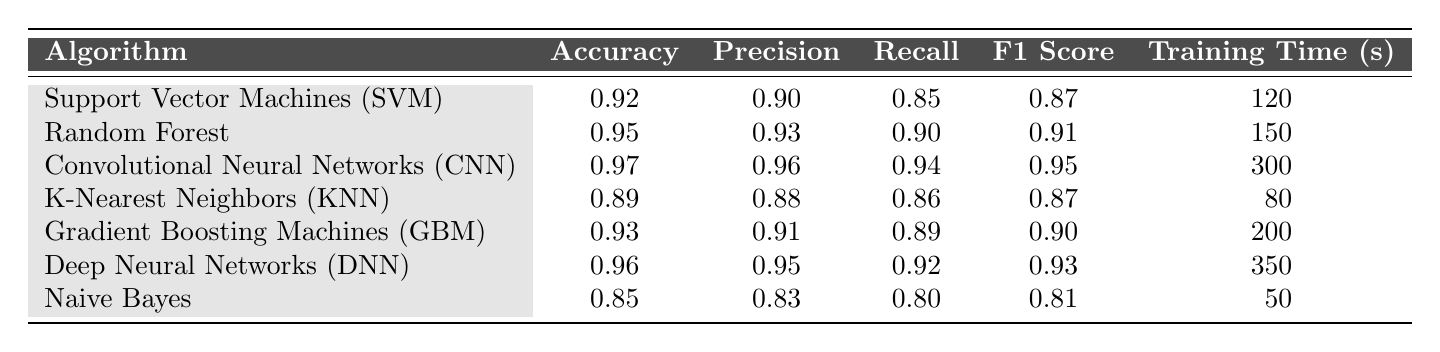What is the accuracy of the Convolutional Neural Networks (CNN)? The accuracy is listed directly under the respective row for CNN in the table, which shows 0.97.
Answer: 0.97 Which algorithm has the lowest precision? By examining the precision values given for each algorithm, Naive Bayes has the lowest precision at 0.83.
Answer: Naive Bayes What is the training time of the Random Forest algorithm? The training time for the Random Forest algorithm is explicitly stated in the table as 150 seconds.
Answer: 150 seconds True or False: The Deep Neural Networks (DNN) algorithm has a higher recall than the Gradient Boosting Machines (GBM). Comparing the recall values of DNN (0.92) and GBM (0.89) shows that DNN has a higher recall, making the statement true.
Answer: True What is the average accuracy of all the algorithms listed? The accuracies are 0.92, 0.95, 0.97, 0.89, 0.93, 0.96, and 0.85. Their sum is 0.92 + 0.95 + 0.97 + 0.89 + 0.93 + 0.96 + 0.85 = 6.47. Dividing by 7 results in an average of approximately 0.93.
Answer: 0.93 Which algorithm offers the best F1 score? The F1 scores are compared: SVM (0.87), Random Forest (0.91), CNN (0.95), KNN (0.87), GBM (0.90), DNN (0.93), and Naive Bayes (0.81). CNN has the highest score at 0.95.
Answer: Convolutional Neural Networks (CNN) Calculate the difference in training time between Deep Neural Networks (DNN) and Naive Bayes. The training time for DNN is 350 seconds and for Naive Bayes is 50 seconds. Thus, the difference is 350 - 50 = 300 seconds.
Answer: 300 seconds Which algorithms have an accuracy above 0.90? By reviewing each accuracy value, the algorithms that meet the criteria are SVM, Random Forest, CNN, GBM, DNN. Naive Bayes has an accuracy of 0.85 which does not meet the criteria.
Answer: SVM, Random Forest, CNN, GBM, DNN Is the recall of K-Nearest Neighbors (KNN) higher than that of Support Vector Machines (SVM)? Checking the recall values, KNN has a value of 0.86 while SVM has 0.85. Therefore, KNN's recall is higher than SVM's.
Answer: Yes What is the sum of all F1 scores? The F1 scores are 0.87, 0.91, 0.95, 0.87, 0.90, 0.93, and 0.81. Adding them gives 0.87 + 0.91 + 0.95 + 0.87 + 0.90 + 0.93 + 0.81 = 6.24.
Answer: 6.24 